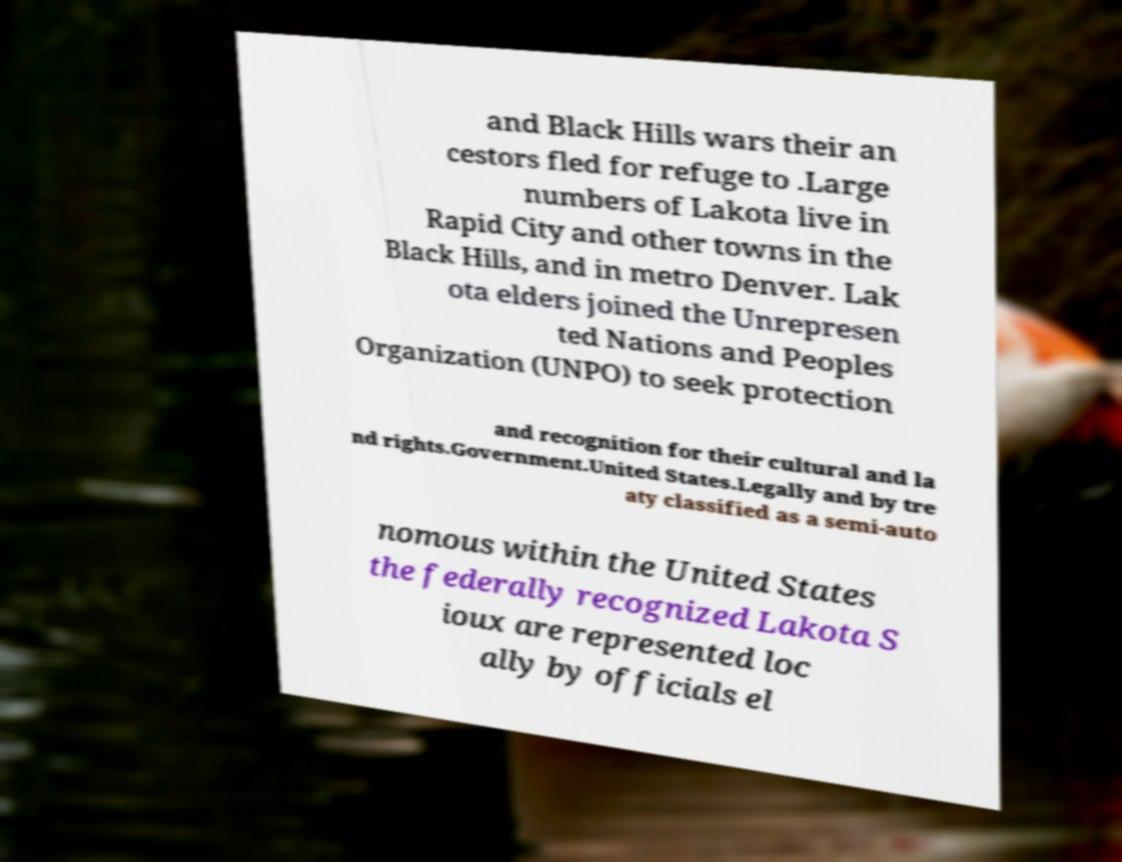I need the written content from this picture converted into text. Can you do that? and Black Hills wars their an cestors fled for refuge to .Large numbers of Lakota live in Rapid City and other towns in the Black Hills, and in metro Denver. Lak ota elders joined the Unrepresen ted Nations and Peoples Organization (UNPO) to seek protection and recognition for their cultural and la nd rights.Government.United States.Legally and by tre aty classified as a semi-auto nomous within the United States the federally recognized Lakota S ioux are represented loc ally by officials el 